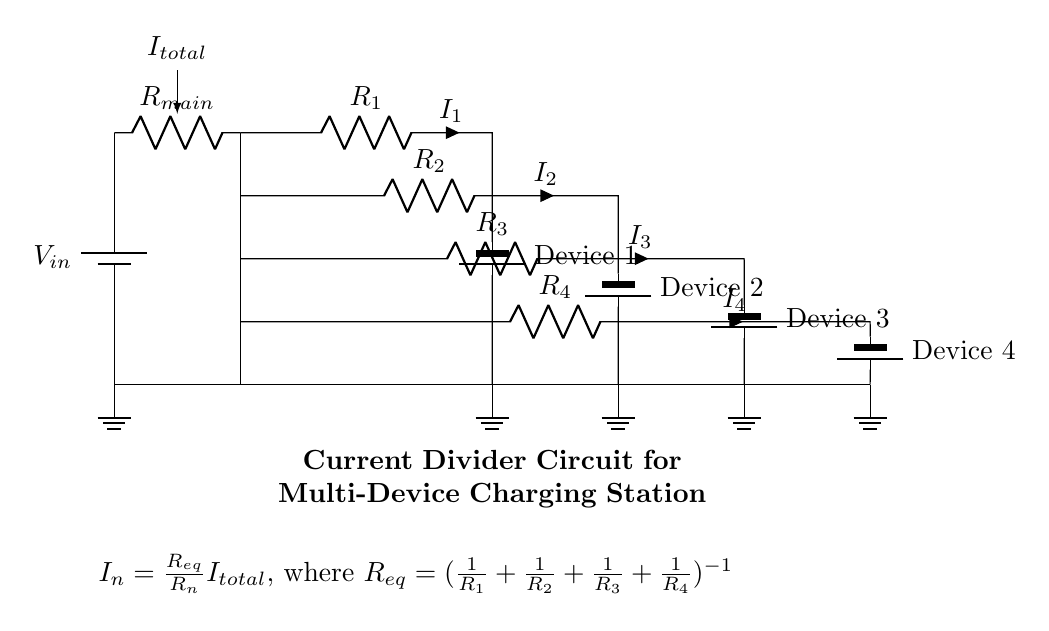What is the input voltage of the circuit? The input voltage is given as V_in, which is shown as the battery symbol in the circuit diagram.
Answer: V_in How many resistors are present in the circuit? There are four resistors depicted in the diagram, labeled R_1, R_2, R_3, and R_4.
Answer: 4 What is the formula for calculating I_n in this circuit? The formula for calculating I_n is provided in the diagram: I_n = (R_eq / R_n) * I_total, where R_eq is the equivalent resistance of the resistors.
Answer: I_n = (R_eq / R_n) * I_total Which device corresponds to the current I_3? The current I_3 corresponds to Device 3, indicated in the diagram next to resistor R_3.
Answer: Device 3 What is the equivalent resistance formula in this current divider? The equivalent resistance formula is given in the circuit: R_eq = (1 / R_1 + 1 / R_2 + 1 / R_3 + 1 / R_4)^(-1).
Answer: R_eq = (1 / R_1 + 1 / R_2 + 1 / R_3 + 1 / R_4)^(-1) What happens to the total current if one resistor is removed? Removing one resistor would increase the equivalent resistance, thereby decreasing the total current based on the current divider principle.
Answer: Decreases 